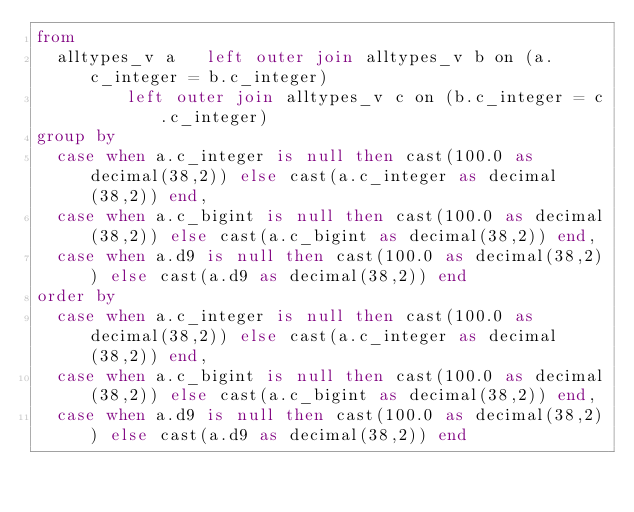Convert code to text. <code><loc_0><loc_0><loc_500><loc_500><_SQL_>from                                            
	alltypes_v a   left outer join alltypes_v b on (a.c_integer = b.c_integer)                         
		     left outer join alltypes_v c on (b.c_integer = c.c_integer)                 
group by
	case when a.c_integer is null then cast(100.0 as decimal(38,2)) else cast(a.c_integer as decimal(38,2)) end,
	case when a.c_bigint is null then cast(100.0 as decimal(38,2)) else cast(a.c_bigint as decimal(38,2)) end,
	case when a.d9 is null then cast(100.0 as decimal(38,2)) else cast(a.d9 as decimal(38,2)) end
order by
	case when a.c_integer is null then cast(100.0 as decimal(38,2)) else cast(a.c_integer as decimal(38,2)) end,
	case when a.c_bigint is null then cast(100.0 as decimal(38,2)) else cast(a.c_bigint as decimal(38,2)) end,
	case when a.d9 is null then cast(100.0 as decimal(38,2)) else cast(a.d9 as decimal(38,2)) end
	
</code> 